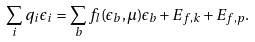<formula> <loc_0><loc_0><loc_500><loc_500>\sum _ { i } q _ { i } \epsilon _ { i } = \sum _ { b } f _ { l } ( \epsilon _ { b } , \mu ) \epsilon _ { b } + E _ { f , k } + E _ { f , p } .</formula> 